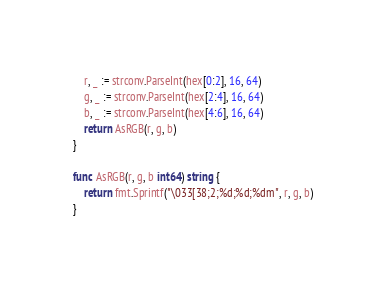<code> <loc_0><loc_0><loc_500><loc_500><_Go_>	r, _ := strconv.ParseInt(hex[0:2], 16, 64)
	g, _ := strconv.ParseInt(hex[2:4], 16, 64)
	b, _ := strconv.ParseInt(hex[4:6], 16, 64)
	return AsRGB(r, g, b)
}

func AsRGB(r, g, b int64) string {
	return fmt.Sprintf("\033[38;2;%d;%d;%dm", r, g, b)
}
</code> 